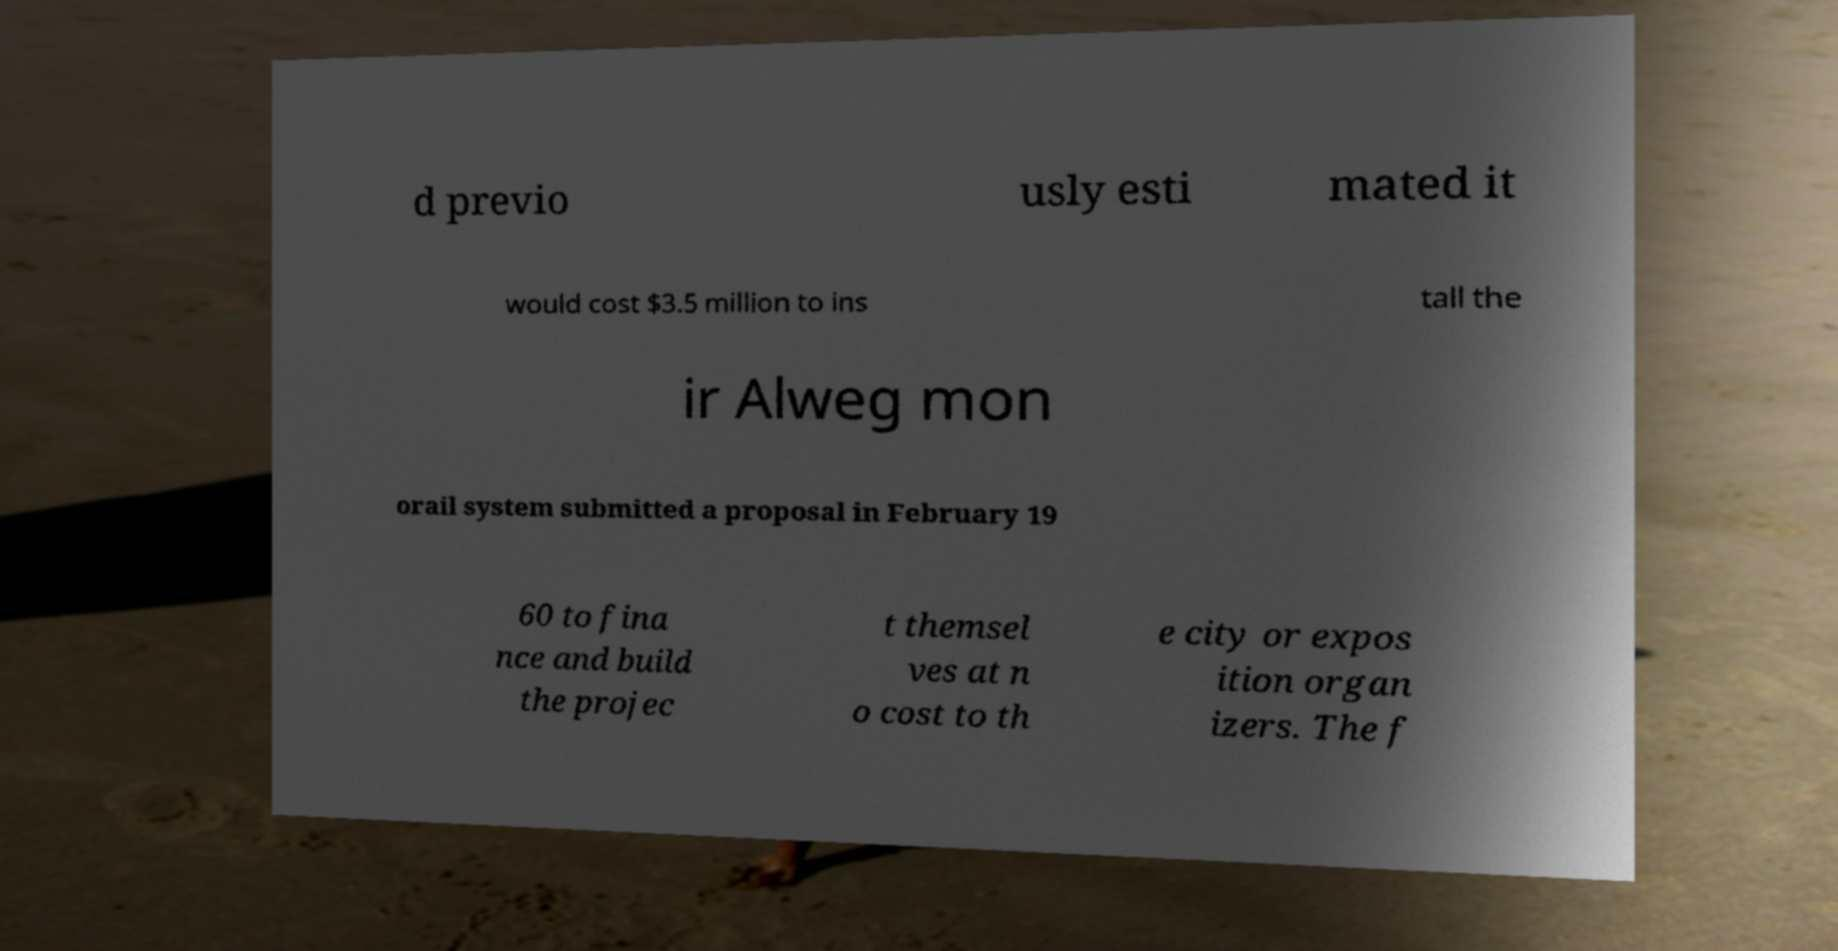Can you read and provide the text displayed in the image?This photo seems to have some interesting text. Can you extract and type it out for me? d previo usly esti mated it would cost $3.5 million to ins tall the ir Alweg mon orail system submitted a proposal in February 19 60 to fina nce and build the projec t themsel ves at n o cost to th e city or expos ition organ izers. The f 